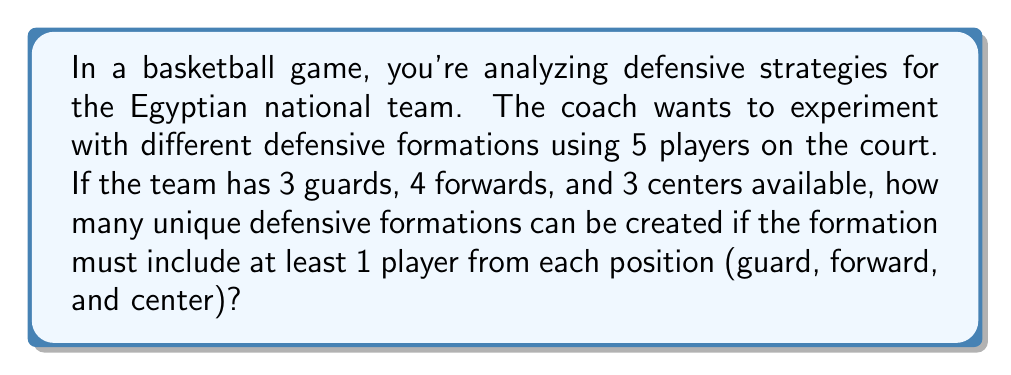Can you answer this question? Let's approach this step-by-step:

1) We need to select 5 players in total, with at least one from each position.

2) Let's consider the possible combinations for each position:
   - Guards: We must select at least 1 and at most 3 guards.
   - Forwards: We must select at least 1 and at most 3 forwards.
   - Centers: We must select at least 1 and at most 2 centers.

3) We can use the combination formula to calculate the number of ways to select players from each position:

4) For guards:
   $${3 \choose 1} + {3 \choose 2} + {3 \choose 3} = 3 + 3 + 1 = 7$$

5) For forwards:
   $${4 \choose 1} + {4 \choose 2} + {4 \choose 3} = 4 + 6 + 4 = 14$$

6) For centers:
   $${3 \choose 1} + {3 \choose 2} = 3 + 3 = 6$$

7) Now, we need to consider all possible combinations of these selections that sum to 5 players:
   - 1 guard, 3 forwards, 1 center
   - 1 guard, 2 forwards, 2 centers
   - 2 guards, 2 forwards, 1 center
   - 2 guards, 1 forward, 2 centers
   - 3 guards, 1 forward, 1 center

8) For each of these combinations, we multiply the number of ways to select from each position:
   $$(3 \times 4 \times 3) + (3 \times 6 \times 3) + (3 \times 6 \times 3) + (3 \times 4 \times 3) + (1 \times 4 \times 3)$$

9) Simplifying:
   $$36 + 54 + 54 + 36 + 12 = 192$$

Therefore, there are 192 unique defensive formations possible.
Answer: 192 unique defensive formations 